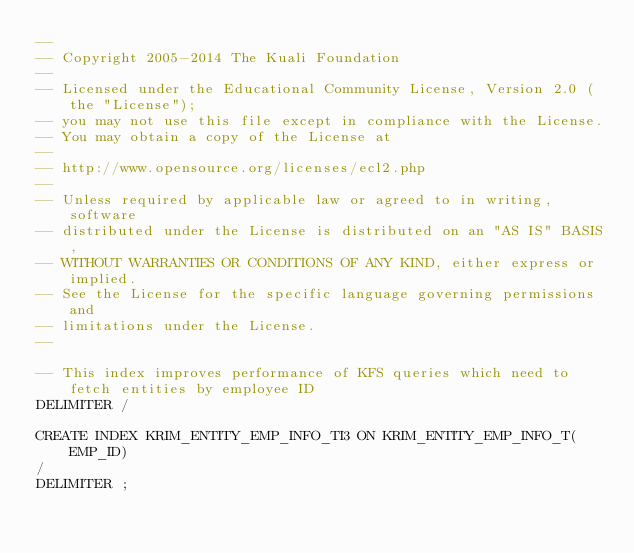<code> <loc_0><loc_0><loc_500><loc_500><_SQL_>--
-- Copyright 2005-2014 The Kuali Foundation
--
-- Licensed under the Educational Community License, Version 2.0 (the "License");
-- you may not use this file except in compliance with the License.
-- You may obtain a copy of the License at
--
-- http://www.opensource.org/licenses/ecl2.php
--
-- Unless required by applicable law or agreed to in writing, software
-- distributed under the License is distributed on an "AS IS" BASIS,
-- WITHOUT WARRANTIES OR CONDITIONS OF ANY KIND, either express or implied.
-- See the License for the specific language governing permissions and
-- limitations under the License.
--

-- This index improves performance of KFS queries which need to fetch entities by employee ID
DELIMITER /

CREATE INDEX KRIM_ENTITY_EMP_INFO_TI3 ON KRIM_ENTITY_EMP_INFO_T(EMP_ID)
/
DELIMITER ;
</code> 